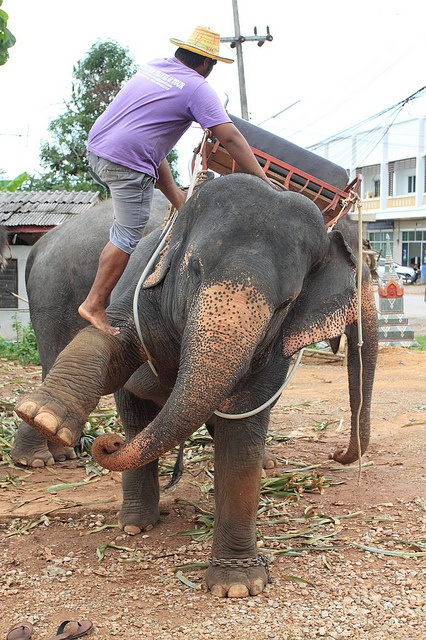Describe the objects in this image and their specific colors. I can see elephant in olive, gray, black, and maroon tones and people in olive, lavender, violet, gray, and darkgray tones in this image. 